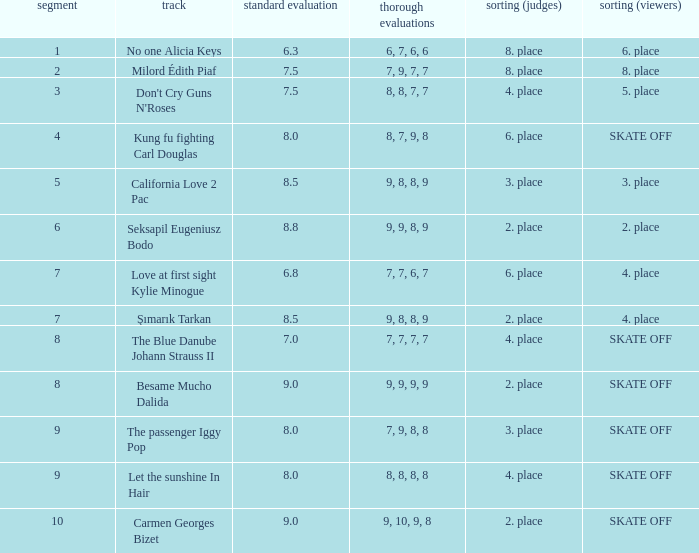Name the average grade for şımarık tarkan 8.5. 